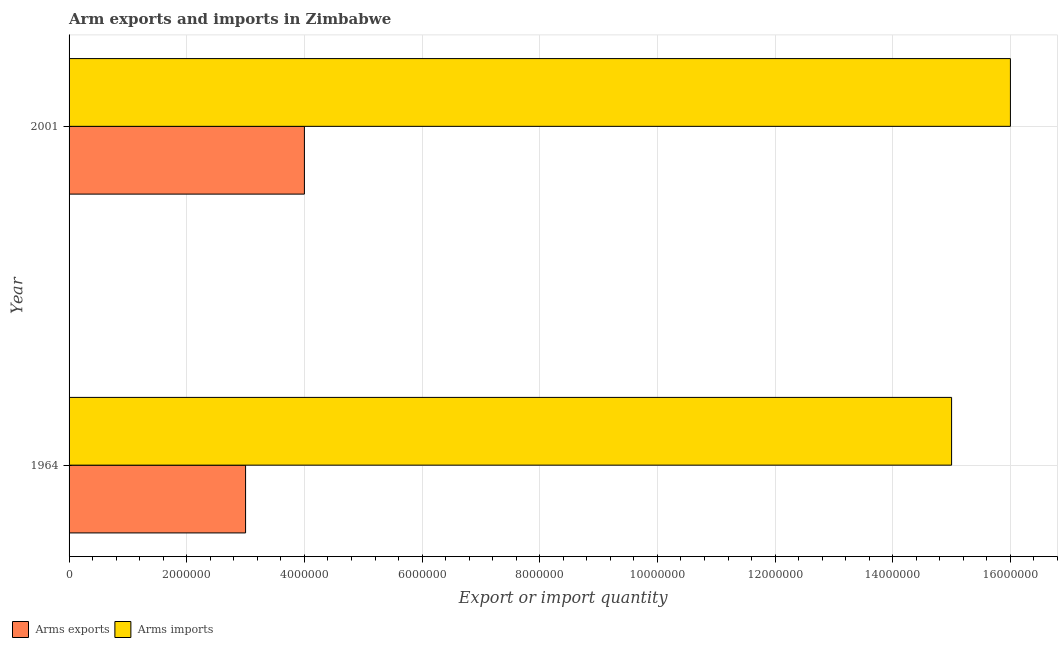How many different coloured bars are there?
Keep it short and to the point. 2. How many groups of bars are there?
Provide a short and direct response. 2. Are the number of bars per tick equal to the number of legend labels?
Make the answer very short. Yes. How many bars are there on the 2nd tick from the bottom?
Your answer should be very brief. 2. What is the arms imports in 1964?
Your response must be concise. 1.50e+07. Across all years, what is the maximum arms exports?
Provide a short and direct response. 4.00e+06. Across all years, what is the minimum arms imports?
Give a very brief answer. 1.50e+07. In which year was the arms imports minimum?
Ensure brevity in your answer.  1964. What is the total arms imports in the graph?
Provide a succinct answer. 3.10e+07. What is the difference between the arms exports in 1964 and that in 2001?
Your answer should be very brief. -1.00e+06. What is the difference between the arms imports in 2001 and the arms exports in 1964?
Provide a short and direct response. 1.30e+07. What is the average arms exports per year?
Make the answer very short. 3.50e+06. In the year 2001, what is the difference between the arms exports and arms imports?
Keep it short and to the point. -1.20e+07. In how many years, is the arms imports greater than 13200000 ?
Offer a very short reply. 2. Is the arms exports in 1964 less than that in 2001?
Give a very brief answer. Yes. Is the difference between the arms imports in 1964 and 2001 greater than the difference between the arms exports in 1964 and 2001?
Give a very brief answer. No. What does the 2nd bar from the top in 1964 represents?
Ensure brevity in your answer.  Arms exports. What does the 1st bar from the bottom in 1964 represents?
Offer a very short reply. Arms exports. Are all the bars in the graph horizontal?
Keep it short and to the point. Yes. How many years are there in the graph?
Your answer should be compact. 2. Where does the legend appear in the graph?
Your answer should be very brief. Bottom left. How are the legend labels stacked?
Provide a short and direct response. Horizontal. What is the title of the graph?
Offer a very short reply. Arm exports and imports in Zimbabwe. What is the label or title of the X-axis?
Make the answer very short. Export or import quantity. What is the Export or import quantity in Arms imports in 1964?
Offer a terse response. 1.50e+07. What is the Export or import quantity of Arms imports in 2001?
Ensure brevity in your answer.  1.60e+07. Across all years, what is the maximum Export or import quantity in Arms imports?
Your answer should be very brief. 1.60e+07. Across all years, what is the minimum Export or import quantity in Arms imports?
Offer a terse response. 1.50e+07. What is the total Export or import quantity of Arms imports in the graph?
Provide a short and direct response. 3.10e+07. What is the difference between the Export or import quantity of Arms exports in 1964 and that in 2001?
Provide a succinct answer. -1.00e+06. What is the difference between the Export or import quantity of Arms imports in 1964 and that in 2001?
Your answer should be very brief. -1.00e+06. What is the difference between the Export or import quantity in Arms exports in 1964 and the Export or import quantity in Arms imports in 2001?
Give a very brief answer. -1.30e+07. What is the average Export or import quantity in Arms exports per year?
Your response must be concise. 3.50e+06. What is the average Export or import quantity in Arms imports per year?
Offer a terse response. 1.55e+07. In the year 1964, what is the difference between the Export or import quantity in Arms exports and Export or import quantity in Arms imports?
Ensure brevity in your answer.  -1.20e+07. In the year 2001, what is the difference between the Export or import quantity in Arms exports and Export or import quantity in Arms imports?
Your answer should be very brief. -1.20e+07. What is the ratio of the Export or import quantity of Arms imports in 1964 to that in 2001?
Offer a very short reply. 0.94. What is the difference between the highest and the second highest Export or import quantity in Arms exports?
Ensure brevity in your answer.  1.00e+06. What is the difference between the highest and the lowest Export or import quantity of Arms exports?
Ensure brevity in your answer.  1.00e+06. What is the difference between the highest and the lowest Export or import quantity of Arms imports?
Provide a short and direct response. 1.00e+06. 